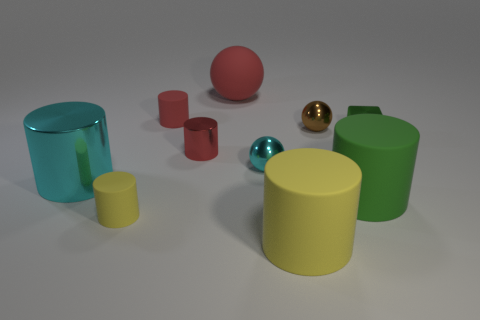Subtract all metallic cylinders. How many cylinders are left? 4 Subtract all gray blocks. How many green cylinders are left? 1 Add 6 green things. How many green things exist? 8 Subtract all red cylinders. How many cylinders are left? 4 Subtract 0 brown cubes. How many objects are left? 10 Subtract all cubes. How many objects are left? 9 Subtract 3 cylinders. How many cylinders are left? 3 Subtract all green spheres. Subtract all brown cubes. How many spheres are left? 3 Subtract all green metal blocks. Subtract all green rubber things. How many objects are left? 8 Add 8 big rubber cylinders. How many big rubber cylinders are left? 10 